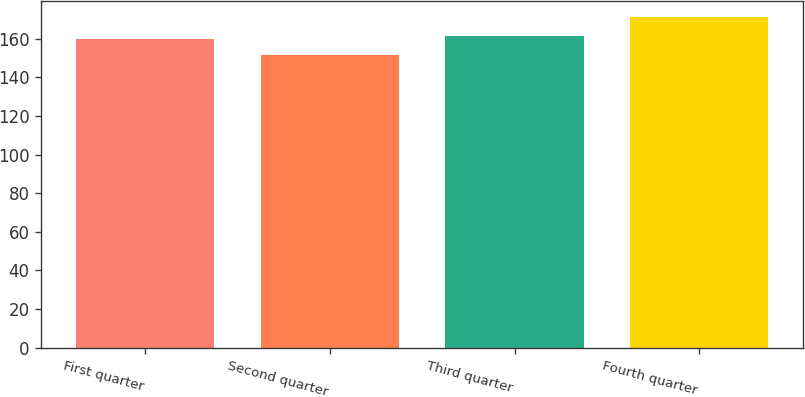<chart> <loc_0><loc_0><loc_500><loc_500><bar_chart><fcel>First quarter<fcel>Second quarter<fcel>Third quarter<fcel>Fourth quarter<nl><fcel>159.77<fcel>151.65<fcel>161.73<fcel>171.26<nl></chart> 